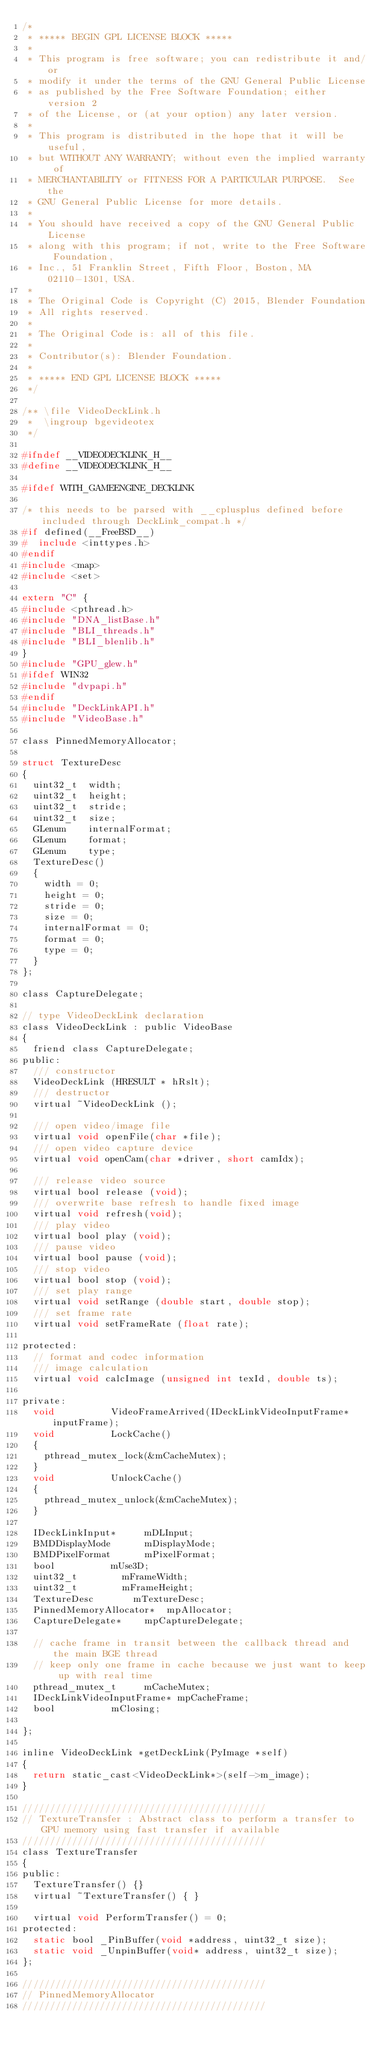<code> <loc_0><loc_0><loc_500><loc_500><_C_>/*
 * ***** BEGIN GPL LICENSE BLOCK *****
 *
 * This program is free software; you can redistribute it and/or
 * modify it under the terms of the GNU General Public License
 * as published by the Free Software Foundation; either version 2
 * of the License, or (at your option) any later version.
 *
 * This program is distributed in the hope that it will be useful,
 * but WITHOUT ANY WARRANTY; without even the implied warranty of
 * MERCHANTABILITY or FITNESS FOR A PARTICULAR PURPOSE.  See the
 * GNU General Public License for more details.
 *
 * You should have received a copy of the GNU General Public License
 * along with this program; if not, write to the Free Software Foundation,
 * Inc., 51 Franklin Street, Fifth Floor, Boston, MA 02110-1301, USA.
 *
 * The Original Code is Copyright (C) 2015, Blender Foundation
 * All rights reserved.
 *
 * The Original Code is: all of this file.
 *
 * Contributor(s): Blender Foundation.
 *
 * ***** END GPL LICENSE BLOCK *****
 */

/** \file VideoDeckLink.h
 *  \ingroup bgevideotex
 */

#ifndef __VIDEODECKLINK_H__
#define __VIDEODECKLINK_H__

#ifdef WITH_GAMEENGINE_DECKLINK

/* this needs to be parsed with __cplusplus defined before included through DeckLink_compat.h */
#if defined(__FreeBSD__)
#  include <inttypes.h>
#endif
#include <map>
#include <set>

extern "C" {
#include <pthread.h>
#include "DNA_listBase.h"
#include "BLI_threads.h"
#include "BLI_blenlib.h"
}
#include "GPU_glew.h"
#ifdef WIN32
#include "dvpapi.h"
#endif
#include "DeckLinkAPI.h"
#include "VideoBase.h"

class PinnedMemoryAllocator;

struct TextureDesc
{
	uint32_t	width;
	uint32_t	height;
	uint32_t	stride;
	uint32_t	size;
	GLenum		internalFormat;
	GLenum		format;
	GLenum		type;
	TextureDesc()
	{
		width = 0;
		height = 0;
		stride = 0;
		size = 0;
		internalFormat = 0;
		format = 0;
		type = 0;
	}
};

class CaptureDelegate;

// type VideoDeckLink declaration
class VideoDeckLink : public VideoBase
{
	friend class CaptureDelegate;
public:
	/// constructor
	VideoDeckLink (HRESULT * hRslt);
	/// destructor
	virtual ~VideoDeckLink ();

	/// open video/image file
	virtual void openFile(char *file);
	/// open video capture device
	virtual void openCam(char *driver, short camIdx);

	/// release video source
	virtual bool release (void);
	/// overwrite base refresh to handle fixed image
	virtual void refresh(void);
	/// play video
	virtual bool play (void);
	/// pause video
	virtual bool pause (void);
	/// stop video
	virtual bool stop (void);
	/// set play range
	virtual void setRange (double start, double stop);
	/// set frame rate
	virtual void setFrameRate (float rate);

protected:
	// format and codec information
	/// image calculation
	virtual void calcImage (unsigned int texId, double ts);

private:
	void					VideoFrameArrived(IDeckLinkVideoInputFrame* inputFrame);
	void					LockCache()
	{
		pthread_mutex_lock(&mCacheMutex);
	}
	void					UnlockCache()
	{
		pthread_mutex_unlock(&mCacheMutex);
	}

	IDeckLinkInput*			mDLInput;
	BMDDisplayMode			mDisplayMode;
	BMDPixelFormat			mPixelFormat;
	bool					mUse3D;
	uint32_t				mFrameWidth;
	uint32_t				mFrameHeight;
	TextureDesc				mTextureDesc;
	PinnedMemoryAllocator*	mpAllocator;
	CaptureDelegate*		mpCaptureDelegate;

	// cache frame in transit between the callback thread and the main BGE thread
	// keep only one frame in cache because we just want to keep up with real time
	pthread_mutex_t			mCacheMutex;
	IDeckLinkVideoInputFrame* mpCacheFrame;
	bool					mClosing;

};

inline VideoDeckLink *getDeckLink(PyImage *self)
{
	return static_cast<VideoDeckLink*>(self->m_image);
}

////////////////////////////////////////////
// TextureTransfer : Abstract class to perform a transfer to GPU memory using fast transfer if available
////////////////////////////////////////////
class TextureTransfer
{
public:
	TextureTransfer() {}
	virtual ~TextureTransfer() { }

	virtual void PerformTransfer() = 0;
protected:
	static bool _PinBuffer(void *address, uint32_t size);
	static void _UnpinBuffer(void* address, uint32_t size);
};

////////////////////////////////////////////
// PinnedMemoryAllocator
////////////////////////////////////////////
</code> 